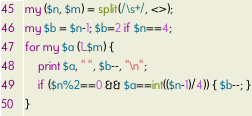<code> <loc_0><loc_0><loc_500><loc_500><_Perl_>my ($n, $m) = split(/\s+/, <>);
my $b = $n-1; $b=2 if $n==4;
for my $a (1..$m) {
    print $a, " ", $b--, "\n";
    if ($n%2==0 && $a==int(($n-1)/4)) { $b--; }
}
</code> 